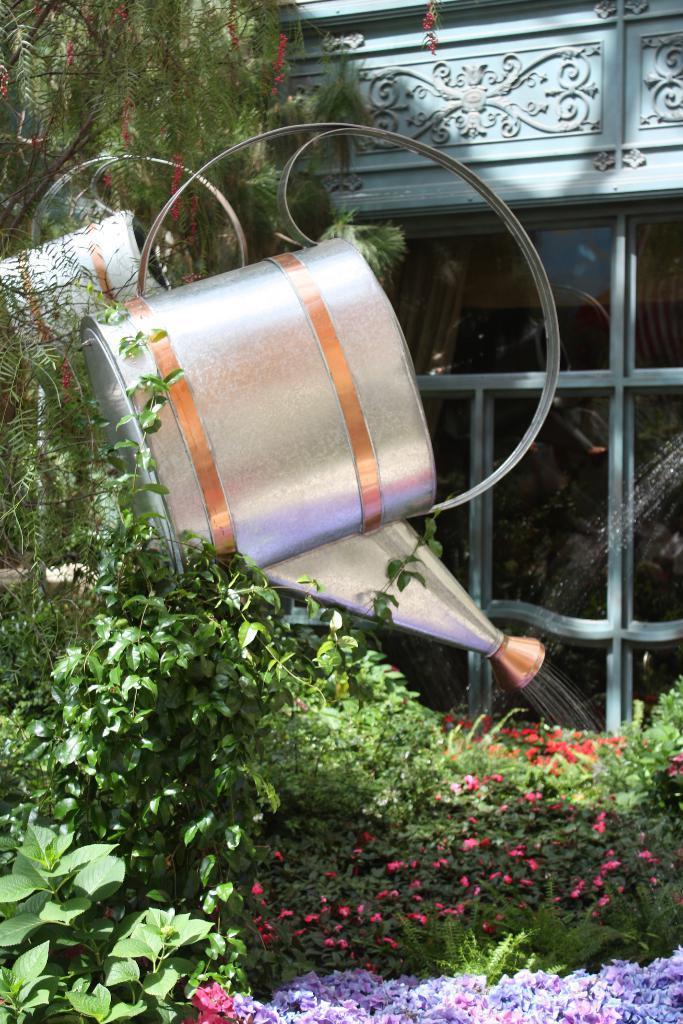Can you describe this image briefly? In this image we can see a water can, here are the plants, here are the flowers, here is the glass door. 